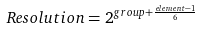Convert formula to latex. <formula><loc_0><loc_0><loc_500><loc_500>R e s o l u t i o n = 2 ^ { { g r o u p } + { \frac { e l e m e n t - 1 } { 6 } } }</formula> 